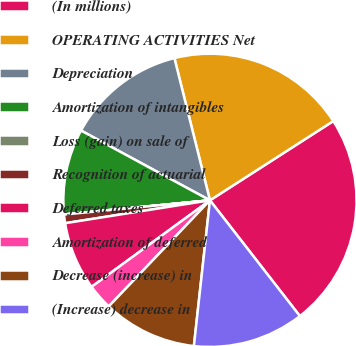<chart> <loc_0><loc_0><loc_500><loc_500><pie_chart><fcel>(In millions)<fcel>OPERATING ACTIVITIES Net<fcel>Depreciation<fcel>Amortization of intangibles<fcel>Loss (gain) on sale of<fcel>Recognition of actuarial<fcel>Deferred taxes<fcel>Amortization of deferred<fcel>Decrease (increase) in<fcel>(Increase) decrease in<nl><fcel>23.58%<fcel>19.81%<fcel>13.21%<fcel>9.43%<fcel>0.01%<fcel>0.95%<fcel>7.55%<fcel>2.83%<fcel>10.38%<fcel>12.26%<nl></chart> 